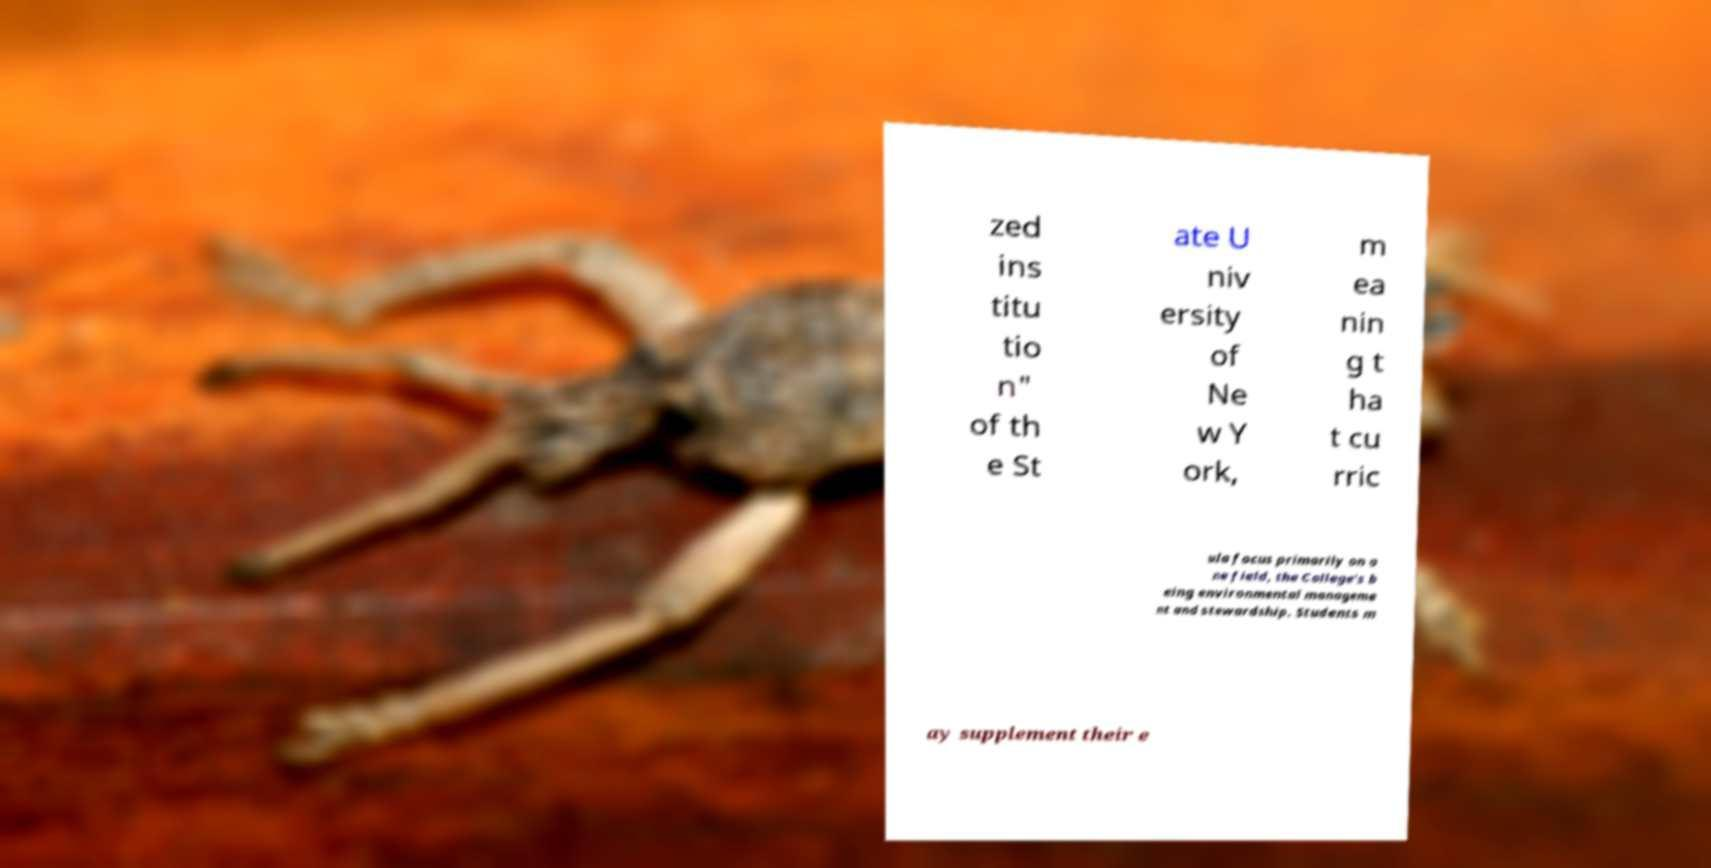There's text embedded in this image that I need extracted. Can you transcribe it verbatim? zed ins titu tio n" of th e St ate U niv ersity of Ne w Y ork, m ea nin g t ha t cu rric ula focus primarily on o ne field, the College's b eing environmental manageme nt and stewardship. Students m ay supplement their e 